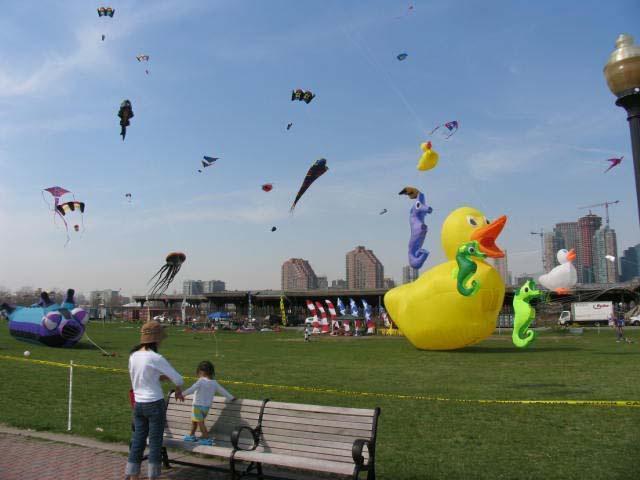How many seagulls are on the bench?
Give a very brief answer. 0. 